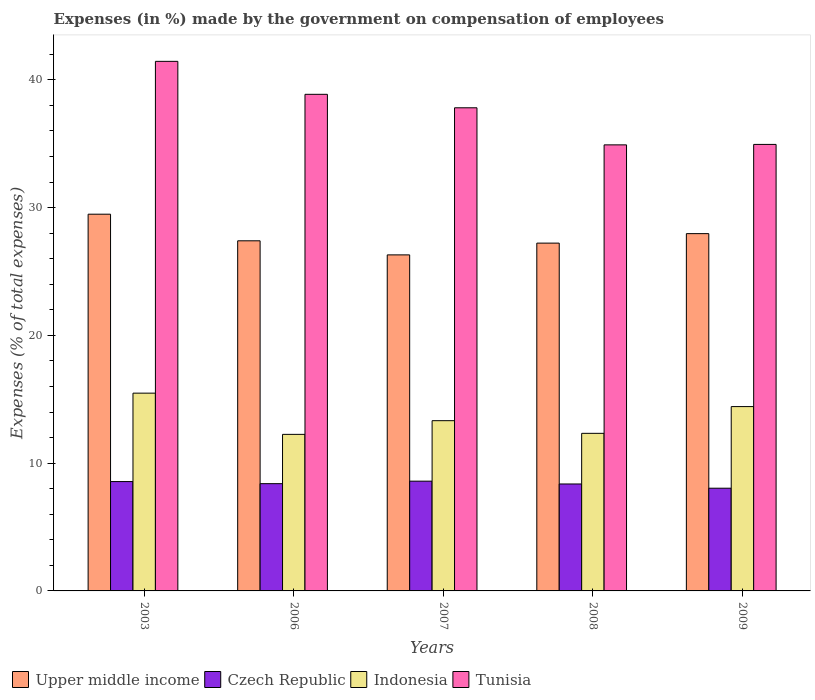How many different coloured bars are there?
Make the answer very short. 4. How many groups of bars are there?
Your answer should be very brief. 5. How many bars are there on the 4th tick from the right?
Provide a succinct answer. 4. What is the label of the 4th group of bars from the left?
Keep it short and to the point. 2008. What is the percentage of expenses made by the government on compensation of employees in Indonesia in 2007?
Make the answer very short. 13.32. Across all years, what is the maximum percentage of expenses made by the government on compensation of employees in Czech Republic?
Your response must be concise. 8.59. Across all years, what is the minimum percentage of expenses made by the government on compensation of employees in Czech Republic?
Keep it short and to the point. 8.04. In which year was the percentage of expenses made by the government on compensation of employees in Upper middle income maximum?
Provide a succinct answer. 2003. What is the total percentage of expenses made by the government on compensation of employees in Indonesia in the graph?
Ensure brevity in your answer.  67.81. What is the difference between the percentage of expenses made by the government on compensation of employees in Upper middle income in 2007 and that in 2008?
Your answer should be very brief. -0.92. What is the difference between the percentage of expenses made by the government on compensation of employees in Upper middle income in 2007 and the percentage of expenses made by the government on compensation of employees in Czech Republic in 2009?
Offer a terse response. 18.26. What is the average percentage of expenses made by the government on compensation of employees in Czech Republic per year?
Ensure brevity in your answer.  8.39. In the year 2008, what is the difference between the percentage of expenses made by the government on compensation of employees in Upper middle income and percentage of expenses made by the government on compensation of employees in Indonesia?
Offer a very short reply. 14.89. What is the ratio of the percentage of expenses made by the government on compensation of employees in Tunisia in 2006 to that in 2007?
Provide a succinct answer. 1.03. Is the percentage of expenses made by the government on compensation of employees in Indonesia in 2008 less than that in 2009?
Offer a terse response. Yes. What is the difference between the highest and the second highest percentage of expenses made by the government on compensation of employees in Upper middle income?
Your response must be concise. 1.52. What is the difference between the highest and the lowest percentage of expenses made by the government on compensation of employees in Czech Republic?
Offer a terse response. 0.55. In how many years, is the percentage of expenses made by the government on compensation of employees in Czech Republic greater than the average percentage of expenses made by the government on compensation of employees in Czech Republic taken over all years?
Offer a terse response. 3. What does the 2nd bar from the left in 2008 represents?
Your response must be concise. Czech Republic. What does the 1st bar from the right in 2009 represents?
Offer a very short reply. Tunisia. Is it the case that in every year, the sum of the percentage of expenses made by the government on compensation of employees in Czech Republic and percentage of expenses made by the government on compensation of employees in Indonesia is greater than the percentage of expenses made by the government on compensation of employees in Upper middle income?
Your answer should be very brief. No. How many bars are there?
Your response must be concise. 20. Are all the bars in the graph horizontal?
Offer a terse response. No. How many years are there in the graph?
Your response must be concise. 5. What is the difference between two consecutive major ticks on the Y-axis?
Make the answer very short. 10. Does the graph contain any zero values?
Your response must be concise. No. Where does the legend appear in the graph?
Your response must be concise. Bottom left. What is the title of the graph?
Offer a very short reply. Expenses (in %) made by the government on compensation of employees. What is the label or title of the X-axis?
Keep it short and to the point. Years. What is the label or title of the Y-axis?
Provide a short and direct response. Expenses (% of total expenses). What is the Expenses (% of total expenses) of Upper middle income in 2003?
Your response must be concise. 29.48. What is the Expenses (% of total expenses) of Czech Republic in 2003?
Offer a terse response. 8.56. What is the Expenses (% of total expenses) in Indonesia in 2003?
Give a very brief answer. 15.48. What is the Expenses (% of total expenses) of Tunisia in 2003?
Offer a very short reply. 41.44. What is the Expenses (% of total expenses) of Upper middle income in 2006?
Keep it short and to the point. 27.4. What is the Expenses (% of total expenses) of Czech Republic in 2006?
Your response must be concise. 8.39. What is the Expenses (% of total expenses) in Indonesia in 2006?
Offer a terse response. 12.25. What is the Expenses (% of total expenses) in Tunisia in 2006?
Your response must be concise. 38.86. What is the Expenses (% of total expenses) of Upper middle income in 2007?
Your response must be concise. 26.3. What is the Expenses (% of total expenses) of Czech Republic in 2007?
Provide a short and direct response. 8.59. What is the Expenses (% of total expenses) of Indonesia in 2007?
Your answer should be very brief. 13.32. What is the Expenses (% of total expenses) in Tunisia in 2007?
Ensure brevity in your answer.  37.81. What is the Expenses (% of total expenses) in Upper middle income in 2008?
Your answer should be compact. 27.22. What is the Expenses (% of total expenses) in Czech Republic in 2008?
Offer a terse response. 8.37. What is the Expenses (% of total expenses) in Indonesia in 2008?
Keep it short and to the point. 12.33. What is the Expenses (% of total expenses) of Tunisia in 2008?
Ensure brevity in your answer.  34.91. What is the Expenses (% of total expenses) in Upper middle income in 2009?
Offer a terse response. 27.96. What is the Expenses (% of total expenses) in Czech Republic in 2009?
Your response must be concise. 8.04. What is the Expenses (% of total expenses) of Indonesia in 2009?
Your response must be concise. 14.43. What is the Expenses (% of total expenses) in Tunisia in 2009?
Ensure brevity in your answer.  34.94. Across all years, what is the maximum Expenses (% of total expenses) of Upper middle income?
Your answer should be very brief. 29.48. Across all years, what is the maximum Expenses (% of total expenses) of Czech Republic?
Your answer should be compact. 8.59. Across all years, what is the maximum Expenses (% of total expenses) of Indonesia?
Give a very brief answer. 15.48. Across all years, what is the maximum Expenses (% of total expenses) of Tunisia?
Give a very brief answer. 41.44. Across all years, what is the minimum Expenses (% of total expenses) of Upper middle income?
Provide a short and direct response. 26.3. Across all years, what is the minimum Expenses (% of total expenses) of Czech Republic?
Offer a terse response. 8.04. Across all years, what is the minimum Expenses (% of total expenses) in Indonesia?
Your answer should be very brief. 12.25. Across all years, what is the minimum Expenses (% of total expenses) in Tunisia?
Ensure brevity in your answer.  34.91. What is the total Expenses (% of total expenses) in Upper middle income in the graph?
Give a very brief answer. 138.37. What is the total Expenses (% of total expenses) in Czech Republic in the graph?
Make the answer very short. 41.95. What is the total Expenses (% of total expenses) in Indonesia in the graph?
Give a very brief answer. 67.81. What is the total Expenses (% of total expenses) of Tunisia in the graph?
Provide a short and direct response. 187.97. What is the difference between the Expenses (% of total expenses) in Upper middle income in 2003 and that in 2006?
Keep it short and to the point. 2.08. What is the difference between the Expenses (% of total expenses) of Czech Republic in 2003 and that in 2006?
Offer a very short reply. 0.16. What is the difference between the Expenses (% of total expenses) in Indonesia in 2003 and that in 2006?
Make the answer very short. 3.23. What is the difference between the Expenses (% of total expenses) in Tunisia in 2003 and that in 2006?
Provide a succinct answer. 2.58. What is the difference between the Expenses (% of total expenses) of Upper middle income in 2003 and that in 2007?
Provide a succinct answer. 3.18. What is the difference between the Expenses (% of total expenses) of Czech Republic in 2003 and that in 2007?
Offer a terse response. -0.03. What is the difference between the Expenses (% of total expenses) of Indonesia in 2003 and that in 2007?
Offer a terse response. 2.15. What is the difference between the Expenses (% of total expenses) in Tunisia in 2003 and that in 2007?
Your answer should be very brief. 3.63. What is the difference between the Expenses (% of total expenses) in Upper middle income in 2003 and that in 2008?
Make the answer very short. 2.26. What is the difference between the Expenses (% of total expenses) in Czech Republic in 2003 and that in 2008?
Make the answer very short. 0.19. What is the difference between the Expenses (% of total expenses) in Indonesia in 2003 and that in 2008?
Offer a very short reply. 3.14. What is the difference between the Expenses (% of total expenses) in Tunisia in 2003 and that in 2008?
Your response must be concise. 6.54. What is the difference between the Expenses (% of total expenses) of Upper middle income in 2003 and that in 2009?
Offer a very short reply. 1.52. What is the difference between the Expenses (% of total expenses) of Czech Republic in 2003 and that in 2009?
Provide a succinct answer. 0.52. What is the difference between the Expenses (% of total expenses) of Indonesia in 2003 and that in 2009?
Keep it short and to the point. 1.05. What is the difference between the Expenses (% of total expenses) in Tunisia in 2003 and that in 2009?
Your response must be concise. 6.5. What is the difference between the Expenses (% of total expenses) of Upper middle income in 2006 and that in 2007?
Offer a very short reply. 1.1. What is the difference between the Expenses (% of total expenses) in Czech Republic in 2006 and that in 2007?
Your answer should be very brief. -0.2. What is the difference between the Expenses (% of total expenses) of Indonesia in 2006 and that in 2007?
Offer a very short reply. -1.07. What is the difference between the Expenses (% of total expenses) of Tunisia in 2006 and that in 2007?
Make the answer very short. 1.05. What is the difference between the Expenses (% of total expenses) of Upper middle income in 2006 and that in 2008?
Offer a very short reply. 0.18. What is the difference between the Expenses (% of total expenses) of Czech Republic in 2006 and that in 2008?
Give a very brief answer. 0.02. What is the difference between the Expenses (% of total expenses) in Indonesia in 2006 and that in 2008?
Ensure brevity in your answer.  -0.08. What is the difference between the Expenses (% of total expenses) in Tunisia in 2006 and that in 2008?
Your answer should be very brief. 3.96. What is the difference between the Expenses (% of total expenses) of Upper middle income in 2006 and that in 2009?
Your answer should be very brief. -0.56. What is the difference between the Expenses (% of total expenses) in Czech Republic in 2006 and that in 2009?
Keep it short and to the point. 0.36. What is the difference between the Expenses (% of total expenses) in Indonesia in 2006 and that in 2009?
Your answer should be compact. -2.18. What is the difference between the Expenses (% of total expenses) of Tunisia in 2006 and that in 2009?
Make the answer very short. 3.92. What is the difference between the Expenses (% of total expenses) of Upper middle income in 2007 and that in 2008?
Your answer should be very brief. -0.92. What is the difference between the Expenses (% of total expenses) of Czech Republic in 2007 and that in 2008?
Make the answer very short. 0.22. What is the difference between the Expenses (% of total expenses) in Tunisia in 2007 and that in 2008?
Make the answer very short. 2.9. What is the difference between the Expenses (% of total expenses) in Upper middle income in 2007 and that in 2009?
Keep it short and to the point. -1.66. What is the difference between the Expenses (% of total expenses) in Czech Republic in 2007 and that in 2009?
Keep it short and to the point. 0.55. What is the difference between the Expenses (% of total expenses) of Indonesia in 2007 and that in 2009?
Ensure brevity in your answer.  -1.1. What is the difference between the Expenses (% of total expenses) of Tunisia in 2007 and that in 2009?
Your answer should be compact. 2.87. What is the difference between the Expenses (% of total expenses) in Upper middle income in 2008 and that in 2009?
Give a very brief answer. -0.74. What is the difference between the Expenses (% of total expenses) in Czech Republic in 2008 and that in 2009?
Keep it short and to the point. 0.33. What is the difference between the Expenses (% of total expenses) in Indonesia in 2008 and that in 2009?
Your response must be concise. -2.09. What is the difference between the Expenses (% of total expenses) of Tunisia in 2008 and that in 2009?
Provide a succinct answer. -0.04. What is the difference between the Expenses (% of total expenses) of Upper middle income in 2003 and the Expenses (% of total expenses) of Czech Republic in 2006?
Ensure brevity in your answer.  21.09. What is the difference between the Expenses (% of total expenses) in Upper middle income in 2003 and the Expenses (% of total expenses) in Indonesia in 2006?
Offer a terse response. 17.23. What is the difference between the Expenses (% of total expenses) of Upper middle income in 2003 and the Expenses (% of total expenses) of Tunisia in 2006?
Offer a terse response. -9.38. What is the difference between the Expenses (% of total expenses) in Czech Republic in 2003 and the Expenses (% of total expenses) in Indonesia in 2006?
Your answer should be compact. -3.69. What is the difference between the Expenses (% of total expenses) in Czech Republic in 2003 and the Expenses (% of total expenses) in Tunisia in 2006?
Provide a succinct answer. -30.31. What is the difference between the Expenses (% of total expenses) of Indonesia in 2003 and the Expenses (% of total expenses) of Tunisia in 2006?
Offer a very short reply. -23.39. What is the difference between the Expenses (% of total expenses) in Upper middle income in 2003 and the Expenses (% of total expenses) in Czech Republic in 2007?
Your response must be concise. 20.89. What is the difference between the Expenses (% of total expenses) in Upper middle income in 2003 and the Expenses (% of total expenses) in Indonesia in 2007?
Your response must be concise. 16.16. What is the difference between the Expenses (% of total expenses) of Upper middle income in 2003 and the Expenses (% of total expenses) of Tunisia in 2007?
Give a very brief answer. -8.33. What is the difference between the Expenses (% of total expenses) in Czech Republic in 2003 and the Expenses (% of total expenses) in Indonesia in 2007?
Offer a very short reply. -4.76. What is the difference between the Expenses (% of total expenses) of Czech Republic in 2003 and the Expenses (% of total expenses) of Tunisia in 2007?
Ensure brevity in your answer.  -29.25. What is the difference between the Expenses (% of total expenses) in Indonesia in 2003 and the Expenses (% of total expenses) in Tunisia in 2007?
Ensure brevity in your answer.  -22.33. What is the difference between the Expenses (% of total expenses) of Upper middle income in 2003 and the Expenses (% of total expenses) of Czech Republic in 2008?
Provide a succinct answer. 21.11. What is the difference between the Expenses (% of total expenses) of Upper middle income in 2003 and the Expenses (% of total expenses) of Indonesia in 2008?
Provide a succinct answer. 17.15. What is the difference between the Expenses (% of total expenses) in Upper middle income in 2003 and the Expenses (% of total expenses) in Tunisia in 2008?
Your answer should be compact. -5.43. What is the difference between the Expenses (% of total expenses) in Czech Republic in 2003 and the Expenses (% of total expenses) in Indonesia in 2008?
Offer a very short reply. -3.78. What is the difference between the Expenses (% of total expenses) of Czech Republic in 2003 and the Expenses (% of total expenses) of Tunisia in 2008?
Make the answer very short. -26.35. What is the difference between the Expenses (% of total expenses) of Indonesia in 2003 and the Expenses (% of total expenses) of Tunisia in 2008?
Provide a short and direct response. -19.43. What is the difference between the Expenses (% of total expenses) in Upper middle income in 2003 and the Expenses (% of total expenses) in Czech Republic in 2009?
Your answer should be very brief. 21.44. What is the difference between the Expenses (% of total expenses) of Upper middle income in 2003 and the Expenses (% of total expenses) of Indonesia in 2009?
Provide a succinct answer. 15.06. What is the difference between the Expenses (% of total expenses) in Upper middle income in 2003 and the Expenses (% of total expenses) in Tunisia in 2009?
Offer a terse response. -5.46. What is the difference between the Expenses (% of total expenses) in Czech Republic in 2003 and the Expenses (% of total expenses) in Indonesia in 2009?
Keep it short and to the point. -5.87. What is the difference between the Expenses (% of total expenses) of Czech Republic in 2003 and the Expenses (% of total expenses) of Tunisia in 2009?
Provide a short and direct response. -26.39. What is the difference between the Expenses (% of total expenses) of Indonesia in 2003 and the Expenses (% of total expenses) of Tunisia in 2009?
Provide a succinct answer. -19.47. What is the difference between the Expenses (% of total expenses) of Upper middle income in 2006 and the Expenses (% of total expenses) of Czech Republic in 2007?
Your answer should be compact. 18.81. What is the difference between the Expenses (% of total expenses) of Upper middle income in 2006 and the Expenses (% of total expenses) of Indonesia in 2007?
Provide a short and direct response. 14.08. What is the difference between the Expenses (% of total expenses) in Upper middle income in 2006 and the Expenses (% of total expenses) in Tunisia in 2007?
Your answer should be compact. -10.41. What is the difference between the Expenses (% of total expenses) of Czech Republic in 2006 and the Expenses (% of total expenses) of Indonesia in 2007?
Provide a succinct answer. -4.93. What is the difference between the Expenses (% of total expenses) in Czech Republic in 2006 and the Expenses (% of total expenses) in Tunisia in 2007?
Offer a terse response. -29.42. What is the difference between the Expenses (% of total expenses) of Indonesia in 2006 and the Expenses (% of total expenses) of Tunisia in 2007?
Your answer should be compact. -25.56. What is the difference between the Expenses (% of total expenses) of Upper middle income in 2006 and the Expenses (% of total expenses) of Czech Republic in 2008?
Ensure brevity in your answer.  19.03. What is the difference between the Expenses (% of total expenses) in Upper middle income in 2006 and the Expenses (% of total expenses) in Indonesia in 2008?
Provide a succinct answer. 15.07. What is the difference between the Expenses (% of total expenses) of Upper middle income in 2006 and the Expenses (% of total expenses) of Tunisia in 2008?
Ensure brevity in your answer.  -7.51. What is the difference between the Expenses (% of total expenses) in Czech Republic in 2006 and the Expenses (% of total expenses) in Indonesia in 2008?
Your answer should be compact. -3.94. What is the difference between the Expenses (% of total expenses) of Czech Republic in 2006 and the Expenses (% of total expenses) of Tunisia in 2008?
Provide a short and direct response. -26.52. What is the difference between the Expenses (% of total expenses) in Indonesia in 2006 and the Expenses (% of total expenses) in Tunisia in 2008?
Your response must be concise. -22.66. What is the difference between the Expenses (% of total expenses) in Upper middle income in 2006 and the Expenses (% of total expenses) in Czech Republic in 2009?
Your answer should be compact. 19.36. What is the difference between the Expenses (% of total expenses) in Upper middle income in 2006 and the Expenses (% of total expenses) in Indonesia in 2009?
Make the answer very short. 12.97. What is the difference between the Expenses (% of total expenses) in Upper middle income in 2006 and the Expenses (% of total expenses) in Tunisia in 2009?
Your answer should be compact. -7.54. What is the difference between the Expenses (% of total expenses) of Czech Republic in 2006 and the Expenses (% of total expenses) of Indonesia in 2009?
Offer a very short reply. -6.03. What is the difference between the Expenses (% of total expenses) in Czech Republic in 2006 and the Expenses (% of total expenses) in Tunisia in 2009?
Provide a short and direct response. -26.55. What is the difference between the Expenses (% of total expenses) in Indonesia in 2006 and the Expenses (% of total expenses) in Tunisia in 2009?
Offer a terse response. -22.69. What is the difference between the Expenses (% of total expenses) in Upper middle income in 2007 and the Expenses (% of total expenses) in Czech Republic in 2008?
Provide a succinct answer. 17.93. What is the difference between the Expenses (% of total expenses) in Upper middle income in 2007 and the Expenses (% of total expenses) in Indonesia in 2008?
Offer a terse response. 13.97. What is the difference between the Expenses (% of total expenses) of Upper middle income in 2007 and the Expenses (% of total expenses) of Tunisia in 2008?
Offer a terse response. -8.61. What is the difference between the Expenses (% of total expenses) in Czech Republic in 2007 and the Expenses (% of total expenses) in Indonesia in 2008?
Make the answer very short. -3.74. What is the difference between the Expenses (% of total expenses) in Czech Republic in 2007 and the Expenses (% of total expenses) in Tunisia in 2008?
Ensure brevity in your answer.  -26.32. What is the difference between the Expenses (% of total expenses) of Indonesia in 2007 and the Expenses (% of total expenses) of Tunisia in 2008?
Provide a short and direct response. -21.59. What is the difference between the Expenses (% of total expenses) in Upper middle income in 2007 and the Expenses (% of total expenses) in Czech Republic in 2009?
Make the answer very short. 18.26. What is the difference between the Expenses (% of total expenses) of Upper middle income in 2007 and the Expenses (% of total expenses) of Indonesia in 2009?
Give a very brief answer. 11.87. What is the difference between the Expenses (% of total expenses) of Upper middle income in 2007 and the Expenses (% of total expenses) of Tunisia in 2009?
Keep it short and to the point. -8.65. What is the difference between the Expenses (% of total expenses) in Czech Republic in 2007 and the Expenses (% of total expenses) in Indonesia in 2009?
Your answer should be very brief. -5.84. What is the difference between the Expenses (% of total expenses) in Czech Republic in 2007 and the Expenses (% of total expenses) in Tunisia in 2009?
Your answer should be very brief. -26.35. What is the difference between the Expenses (% of total expenses) of Indonesia in 2007 and the Expenses (% of total expenses) of Tunisia in 2009?
Provide a short and direct response. -21.62. What is the difference between the Expenses (% of total expenses) in Upper middle income in 2008 and the Expenses (% of total expenses) in Czech Republic in 2009?
Your answer should be compact. 19.18. What is the difference between the Expenses (% of total expenses) in Upper middle income in 2008 and the Expenses (% of total expenses) in Indonesia in 2009?
Provide a succinct answer. 12.79. What is the difference between the Expenses (% of total expenses) of Upper middle income in 2008 and the Expenses (% of total expenses) of Tunisia in 2009?
Provide a succinct answer. -7.72. What is the difference between the Expenses (% of total expenses) of Czech Republic in 2008 and the Expenses (% of total expenses) of Indonesia in 2009?
Give a very brief answer. -6.06. What is the difference between the Expenses (% of total expenses) in Czech Republic in 2008 and the Expenses (% of total expenses) in Tunisia in 2009?
Provide a succinct answer. -26.57. What is the difference between the Expenses (% of total expenses) of Indonesia in 2008 and the Expenses (% of total expenses) of Tunisia in 2009?
Provide a succinct answer. -22.61. What is the average Expenses (% of total expenses) of Upper middle income per year?
Your answer should be very brief. 27.67. What is the average Expenses (% of total expenses) of Czech Republic per year?
Provide a succinct answer. 8.39. What is the average Expenses (% of total expenses) in Indonesia per year?
Give a very brief answer. 13.56. What is the average Expenses (% of total expenses) of Tunisia per year?
Your response must be concise. 37.59. In the year 2003, what is the difference between the Expenses (% of total expenses) in Upper middle income and Expenses (% of total expenses) in Czech Republic?
Provide a short and direct response. 20.93. In the year 2003, what is the difference between the Expenses (% of total expenses) of Upper middle income and Expenses (% of total expenses) of Indonesia?
Provide a succinct answer. 14.01. In the year 2003, what is the difference between the Expenses (% of total expenses) in Upper middle income and Expenses (% of total expenses) in Tunisia?
Make the answer very short. -11.96. In the year 2003, what is the difference between the Expenses (% of total expenses) of Czech Republic and Expenses (% of total expenses) of Indonesia?
Provide a succinct answer. -6.92. In the year 2003, what is the difference between the Expenses (% of total expenses) in Czech Republic and Expenses (% of total expenses) in Tunisia?
Offer a terse response. -32.89. In the year 2003, what is the difference between the Expenses (% of total expenses) of Indonesia and Expenses (% of total expenses) of Tunisia?
Offer a terse response. -25.97. In the year 2006, what is the difference between the Expenses (% of total expenses) in Upper middle income and Expenses (% of total expenses) in Czech Republic?
Keep it short and to the point. 19.01. In the year 2006, what is the difference between the Expenses (% of total expenses) of Upper middle income and Expenses (% of total expenses) of Indonesia?
Provide a succinct answer. 15.15. In the year 2006, what is the difference between the Expenses (% of total expenses) in Upper middle income and Expenses (% of total expenses) in Tunisia?
Make the answer very short. -11.46. In the year 2006, what is the difference between the Expenses (% of total expenses) in Czech Republic and Expenses (% of total expenses) in Indonesia?
Provide a succinct answer. -3.86. In the year 2006, what is the difference between the Expenses (% of total expenses) of Czech Republic and Expenses (% of total expenses) of Tunisia?
Ensure brevity in your answer.  -30.47. In the year 2006, what is the difference between the Expenses (% of total expenses) in Indonesia and Expenses (% of total expenses) in Tunisia?
Your answer should be very brief. -26.61. In the year 2007, what is the difference between the Expenses (% of total expenses) in Upper middle income and Expenses (% of total expenses) in Czech Republic?
Make the answer very short. 17.71. In the year 2007, what is the difference between the Expenses (% of total expenses) of Upper middle income and Expenses (% of total expenses) of Indonesia?
Offer a very short reply. 12.98. In the year 2007, what is the difference between the Expenses (% of total expenses) of Upper middle income and Expenses (% of total expenses) of Tunisia?
Offer a very short reply. -11.51. In the year 2007, what is the difference between the Expenses (% of total expenses) in Czech Republic and Expenses (% of total expenses) in Indonesia?
Provide a short and direct response. -4.73. In the year 2007, what is the difference between the Expenses (% of total expenses) in Czech Republic and Expenses (% of total expenses) in Tunisia?
Give a very brief answer. -29.22. In the year 2007, what is the difference between the Expenses (% of total expenses) of Indonesia and Expenses (% of total expenses) of Tunisia?
Make the answer very short. -24.49. In the year 2008, what is the difference between the Expenses (% of total expenses) of Upper middle income and Expenses (% of total expenses) of Czech Republic?
Make the answer very short. 18.85. In the year 2008, what is the difference between the Expenses (% of total expenses) of Upper middle income and Expenses (% of total expenses) of Indonesia?
Offer a terse response. 14.89. In the year 2008, what is the difference between the Expenses (% of total expenses) in Upper middle income and Expenses (% of total expenses) in Tunisia?
Your response must be concise. -7.69. In the year 2008, what is the difference between the Expenses (% of total expenses) in Czech Republic and Expenses (% of total expenses) in Indonesia?
Make the answer very short. -3.96. In the year 2008, what is the difference between the Expenses (% of total expenses) of Czech Republic and Expenses (% of total expenses) of Tunisia?
Give a very brief answer. -26.54. In the year 2008, what is the difference between the Expenses (% of total expenses) in Indonesia and Expenses (% of total expenses) in Tunisia?
Give a very brief answer. -22.58. In the year 2009, what is the difference between the Expenses (% of total expenses) of Upper middle income and Expenses (% of total expenses) of Czech Republic?
Offer a very short reply. 19.92. In the year 2009, what is the difference between the Expenses (% of total expenses) in Upper middle income and Expenses (% of total expenses) in Indonesia?
Offer a very short reply. 13.54. In the year 2009, what is the difference between the Expenses (% of total expenses) of Upper middle income and Expenses (% of total expenses) of Tunisia?
Keep it short and to the point. -6.98. In the year 2009, what is the difference between the Expenses (% of total expenses) of Czech Republic and Expenses (% of total expenses) of Indonesia?
Offer a very short reply. -6.39. In the year 2009, what is the difference between the Expenses (% of total expenses) in Czech Republic and Expenses (% of total expenses) in Tunisia?
Provide a succinct answer. -26.91. In the year 2009, what is the difference between the Expenses (% of total expenses) of Indonesia and Expenses (% of total expenses) of Tunisia?
Offer a terse response. -20.52. What is the ratio of the Expenses (% of total expenses) of Upper middle income in 2003 to that in 2006?
Your response must be concise. 1.08. What is the ratio of the Expenses (% of total expenses) of Czech Republic in 2003 to that in 2006?
Offer a very short reply. 1.02. What is the ratio of the Expenses (% of total expenses) of Indonesia in 2003 to that in 2006?
Keep it short and to the point. 1.26. What is the ratio of the Expenses (% of total expenses) in Tunisia in 2003 to that in 2006?
Give a very brief answer. 1.07. What is the ratio of the Expenses (% of total expenses) of Upper middle income in 2003 to that in 2007?
Offer a very short reply. 1.12. What is the ratio of the Expenses (% of total expenses) of Indonesia in 2003 to that in 2007?
Provide a succinct answer. 1.16. What is the ratio of the Expenses (% of total expenses) in Tunisia in 2003 to that in 2007?
Ensure brevity in your answer.  1.1. What is the ratio of the Expenses (% of total expenses) in Upper middle income in 2003 to that in 2008?
Provide a short and direct response. 1.08. What is the ratio of the Expenses (% of total expenses) in Czech Republic in 2003 to that in 2008?
Offer a very short reply. 1.02. What is the ratio of the Expenses (% of total expenses) in Indonesia in 2003 to that in 2008?
Provide a short and direct response. 1.25. What is the ratio of the Expenses (% of total expenses) of Tunisia in 2003 to that in 2008?
Your response must be concise. 1.19. What is the ratio of the Expenses (% of total expenses) of Upper middle income in 2003 to that in 2009?
Offer a very short reply. 1.05. What is the ratio of the Expenses (% of total expenses) in Czech Republic in 2003 to that in 2009?
Provide a short and direct response. 1.06. What is the ratio of the Expenses (% of total expenses) of Indonesia in 2003 to that in 2009?
Give a very brief answer. 1.07. What is the ratio of the Expenses (% of total expenses) in Tunisia in 2003 to that in 2009?
Your response must be concise. 1.19. What is the ratio of the Expenses (% of total expenses) in Upper middle income in 2006 to that in 2007?
Provide a short and direct response. 1.04. What is the ratio of the Expenses (% of total expenses) of Czech Republic in 2006 to that in 2007?
Make the answer very short. 0.98. What is the ratio of the Expenses (% of total expenses) in Indonesia in 2006 to that in 2007?
Offer a terse response. 0.92. What is the ratio of the Expenses (% of total expenses) of Tunisia in 2006 to that in 2007?
Offer a very short reply. 1.03. What is the ratio of the Expenses (% of total expenses) of Upper middle income in 2006 to that in 2008?
Offer a terse response. 1.01. What is the ratio of the Expenses (% of total expenses) in Czech Republic in 2006 to that in 2008?
Your answer should be compact. 1. What is the ratio of the Expenses (% of total expenses) of Indonesia in 2006 to that in 2008?
Your answer should be very brief. 0.99. What is the ratio of the Expenses (% of total expenses) of Tunisia in 2006 to that in 2008?
Your response must be concise. 1.11. What is the ratio of the Expenses (% of total expenses) in Upper middle income in 2006 to that in 2009?
Provide a short and direct response. 0.98. What is the ratio of the Expenses (% of total expenses) in Czech Republic in 2006 to that in 2009?
Your response must be concise. 1.04. What is the ratio of the Expenses (% of total expenses) of Indonesia in 2006 to that in 2009?
Your response must be concise. 0.85. What is the ratio of the Expenses (% of total expenses) of Tunisia in 2006 to that in 2009?
Your response must be concise. 1.11. What is the ratio of the Expenses (% of total expenses) in Upper middle income in 2007 to that in 2008?
Your response must be concise. 0.97. What is the ratio of the Expenses (% of total expenses) of Czech Republic in 2007 to that in 2008?
Your response must be concise. 1.03. What is the ratio of the Expenses (% of total expenses) in Indonesia in 2007 to that in 2008?
Your response must be concise. 1.08. What is the ratio of the Expenses (% of total expenses) of Tunisia in 2007 to that in 2008?
Your response must be concise. 1.08. What is the ratio of the Expenses (% of total expenses) of Upper middle income in 2007 to that in 2009?
Provide a short and direct response. 0.94. What is the ratio of the Expenses (% of total expenses) in Czech Republic in 2007 to that in 2009?
Make the answer very short. 1.07. What is the ratio of the Expenses (% of total expenses) in Indonesia in 2007 to that in 2009?
Give a very brief answer. 0.92. What is the ratio of the Expenses (% of total expenses) in Tunisia in 2007 to that in 2009?
Offer a very short reply. 1.08. What is the ratio of the Expenses (% of total expenses) of Upper middle income in 2008 to that in 2009?
Keep it short and to the point. 0.97. What is the ratio of the Expenses (% of total expenses) in Czech Republic in 2008 to that in 2009?
Keep it short and to the point. 1.04. What is the ratio of the Expenses (% of total expenses) of Indonesia in 2008 to that in 2009?
Provide a short and direct response. 0.85. What is the difference between the highest and the second highest Expenses (% of total expenses) of Upper middle income?
Your answer should be very brief. 1.52. What is the difference between the highest and the second highest Expenses (% of total expenses) in Czech Republic?
Keep it short and to the point. 0.03. What is the difference between the highest and the second highest Expenses (% of total expenses) of Indonesia?
Offer a very short reply. 1.05. What is the difference between the highest and the second highest Expenses (% of total expenses) of Tunisia?
Provide a succinct answer. 2.58. What is the difference between the highest and the lowest Expenses (% of total expenses) of Upper middle income?
Offer a very short reply. 3.18. What is the difference between the highest and the lowest Expenses (% of total expenses) of Czech Republic?
Make the answer very short. 0.55. What is the difference between the highest and the lowest Expenses (% of total expenses) of Indonesia?
Your answer should be very brief. 3.23. What is the difference between the highest and the lowest Expenses (% of total expenses) of Tunisia?
Provide a succinct answer. 6.54. 